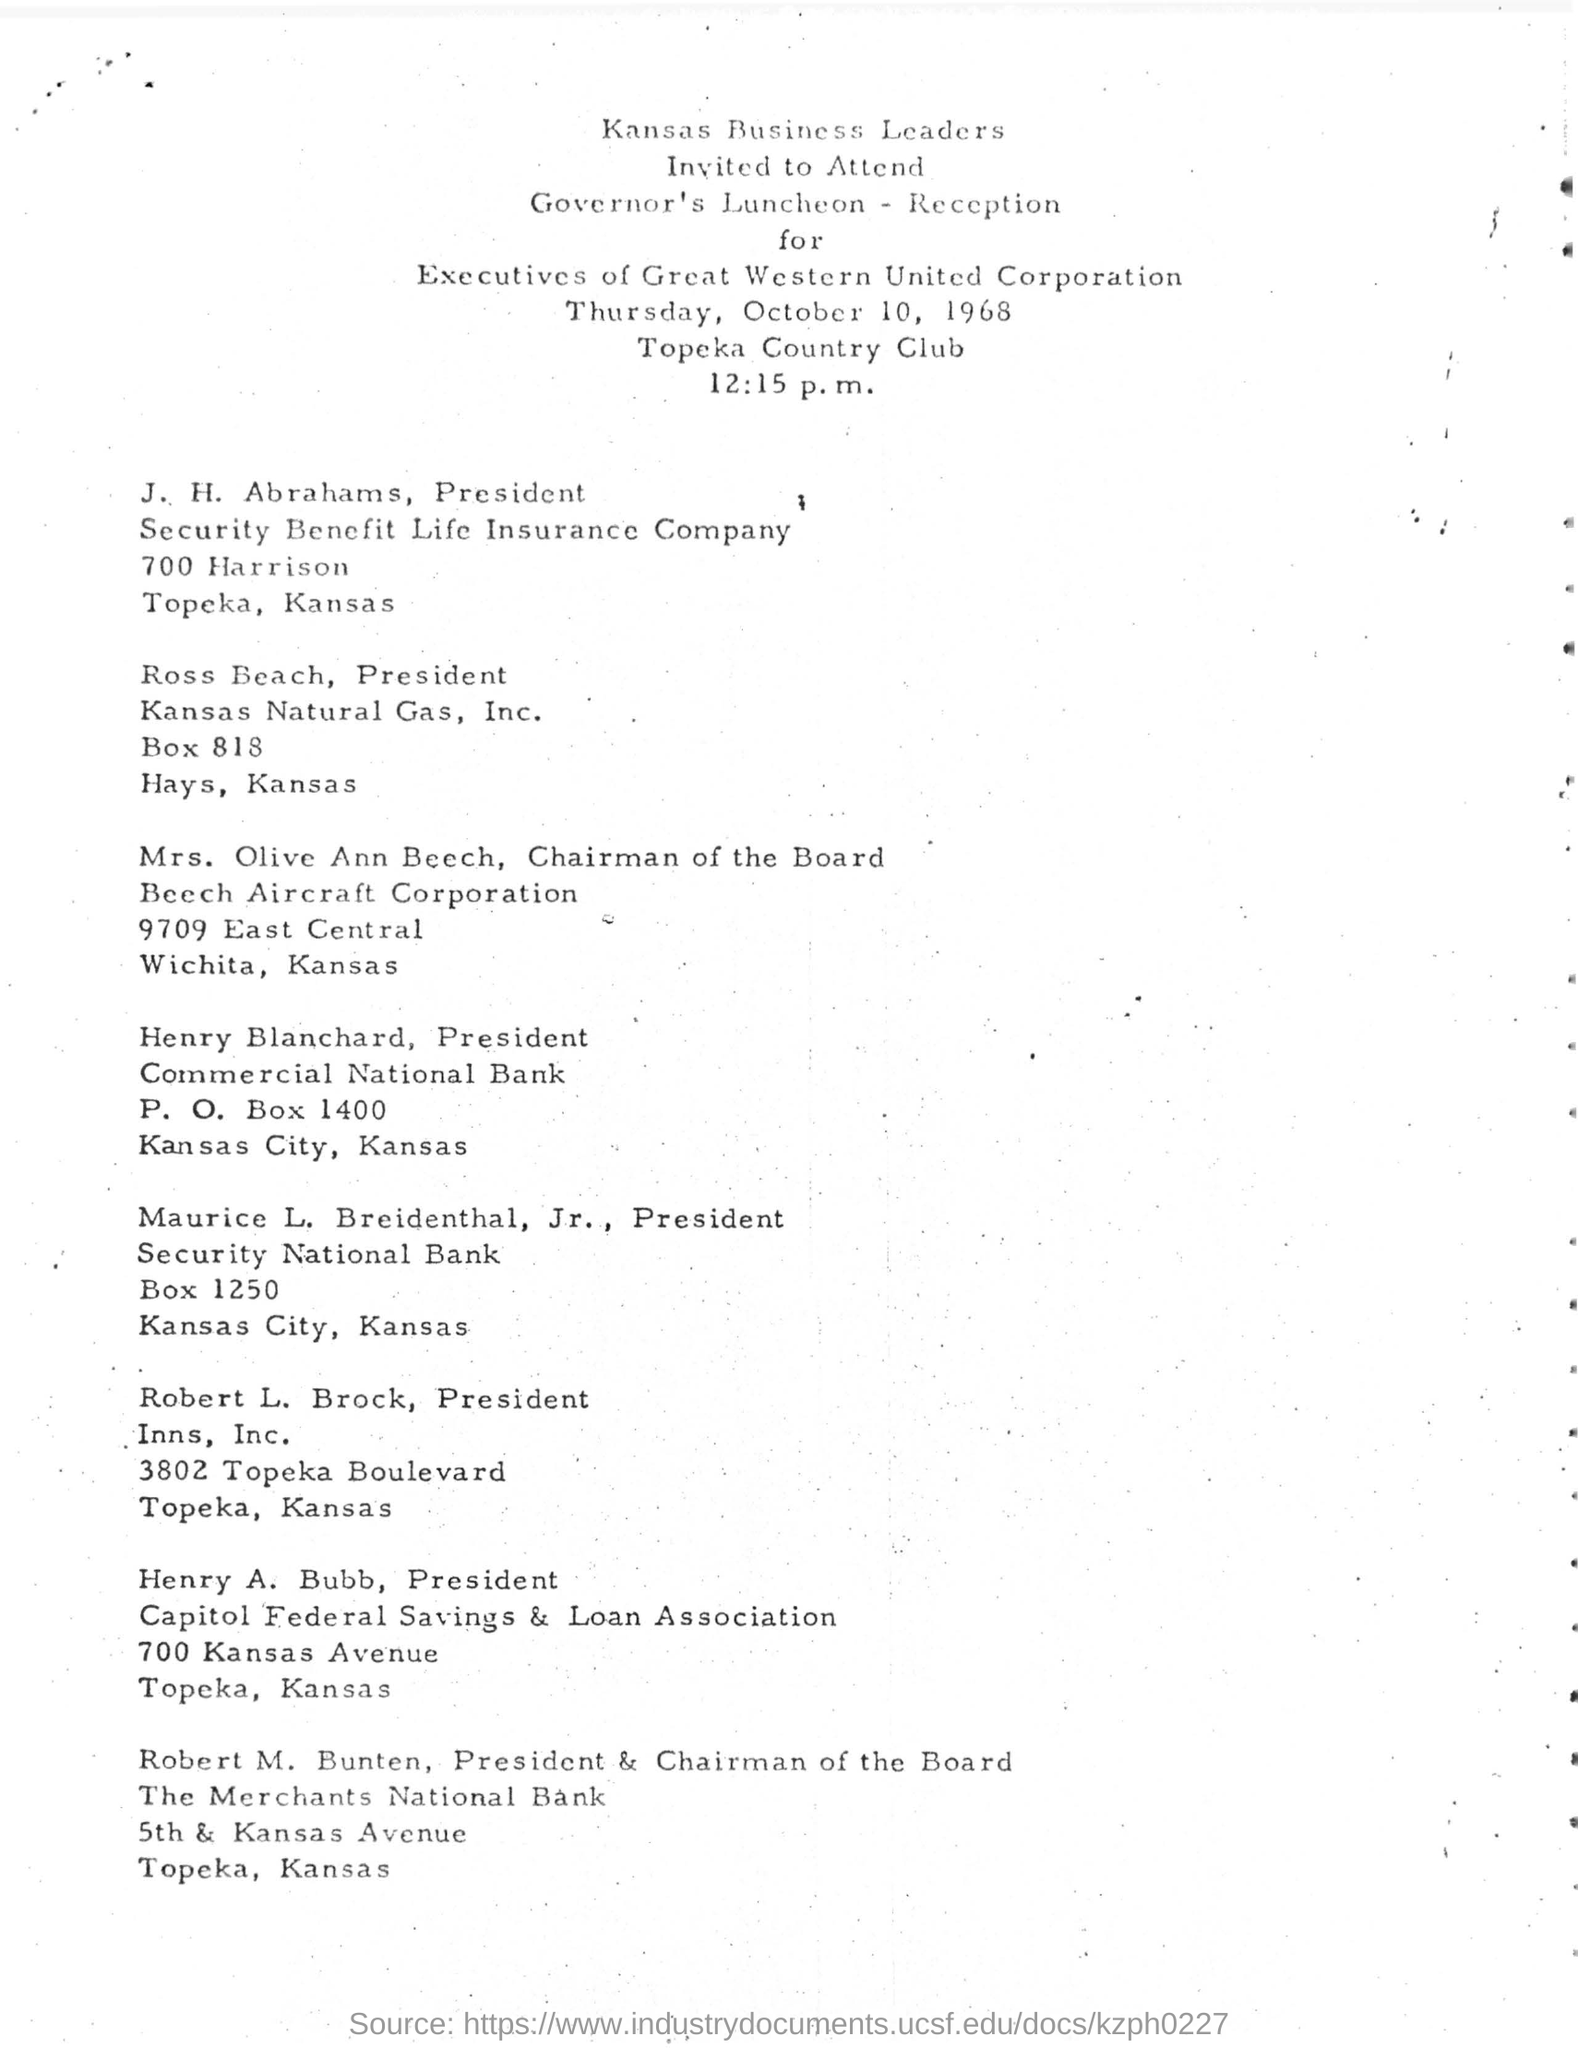What is date mentioned in the document?
Offer a terse response. Thursday, October 10, 1968. Which day is October 10, 1968
Ensure brevity in your answer.  Thursday. What is the time mentioned in this document?
Your response must be concise. 12:15 p. m. What is the P.O box number of Henry Blachard President?
Offer a very short reply. 1400. 